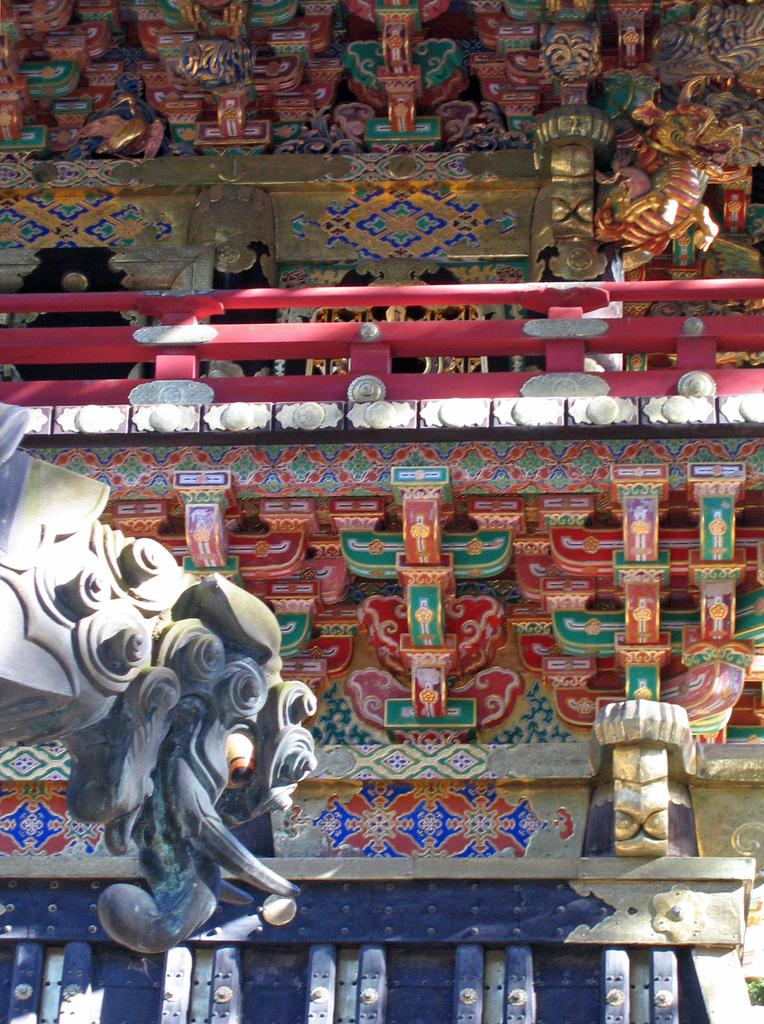What type of artwork is present in the image? There are sculptures in the image. What material are the sculptures made of? The material of the sculptures appears to be wood. What color is the wood? The wood is red in color. How would you describe the appearance of the sculptures? The sculptures are colorful. What type of shoes is the farmer wearing in the image? There is no farmer or shoes present in the image; it features sculptures made of red wood. 